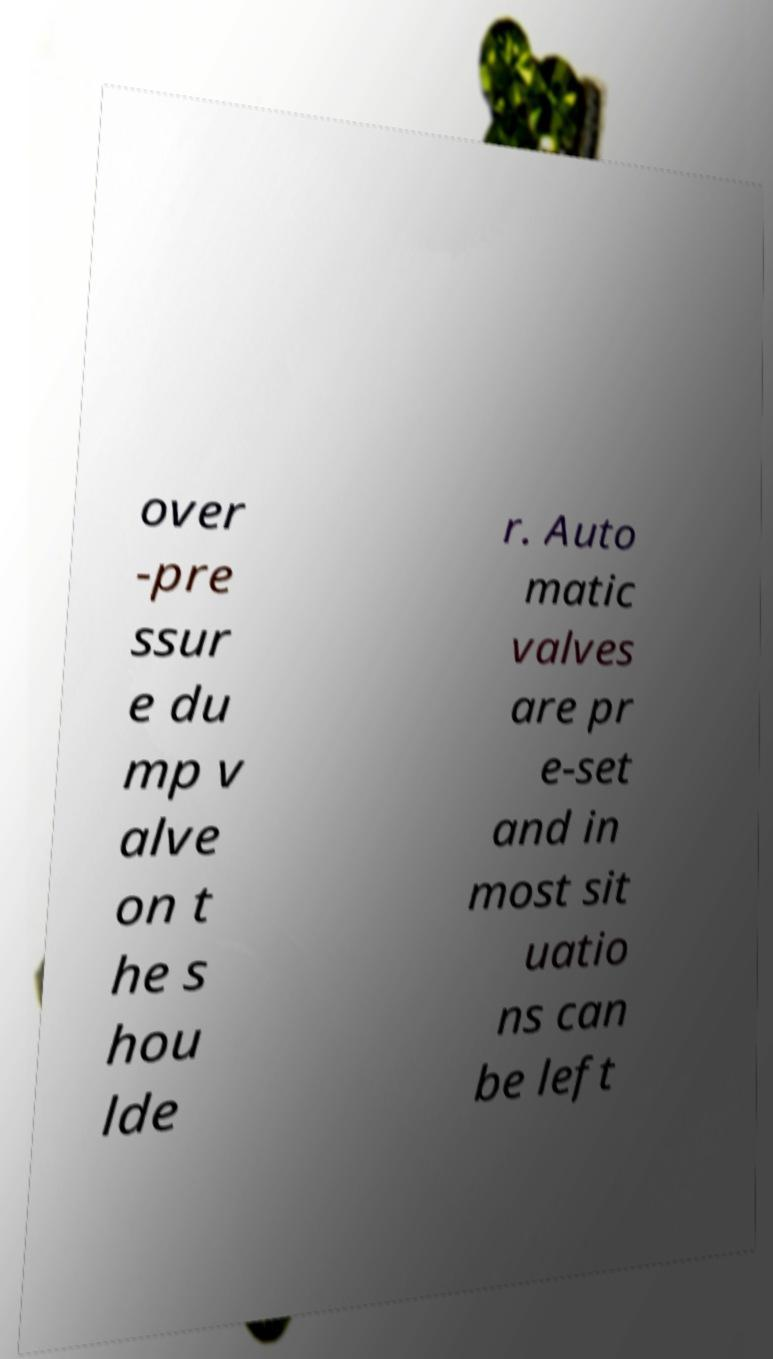Can you accurately transcribe the text from the provided image for me? over -pre ssur e du mp v alve on t he s hou lde r. Auto matic valves are pr e-set and in most sit uatio ns can be left 